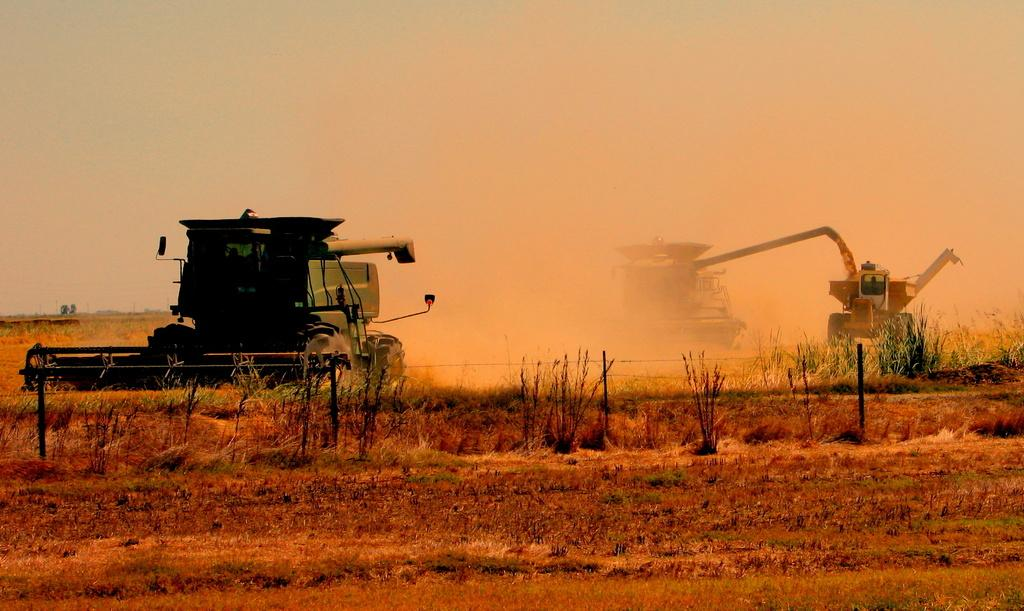What type of machinery is in the center of the image? There are bulldozers in the center of the image. What type of terrain is visible at the bottom of the image? There is grass at the bottom of the image. What can be seen in the background of the image? The sky is visible in the background of the image. How many trees are being stretched by the bulldozers in the image? There are no trees visible in the image, and the bulldozers are not stretching anything. 